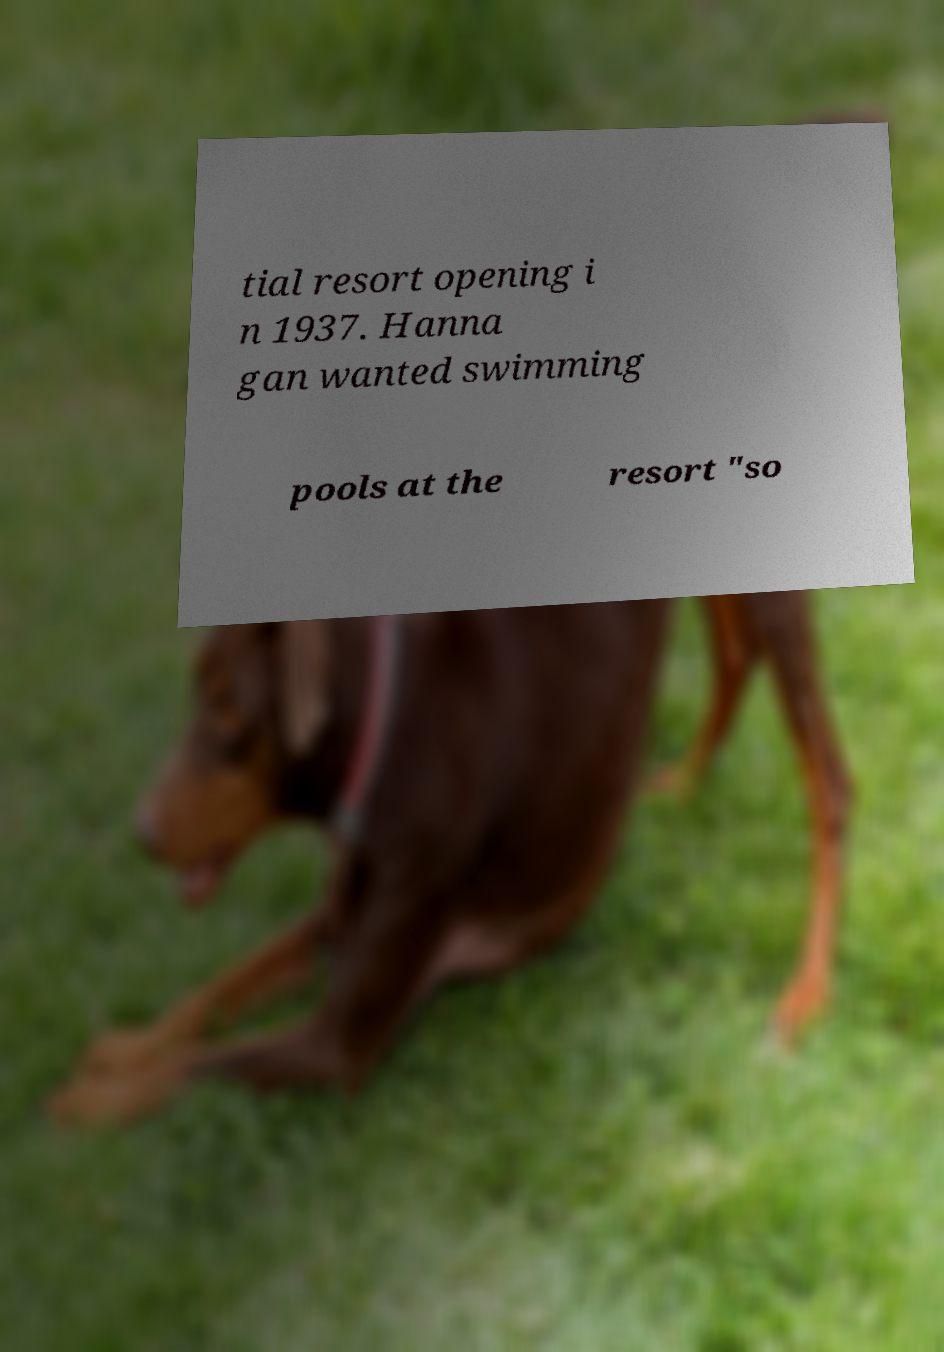Can you read and provide the text displayed in the image?This photo seems to have some interesting text. Can you extract and type it out for me? tial resort opening i n 1937. Hanna gan wanted swimming pools at the resort "so 